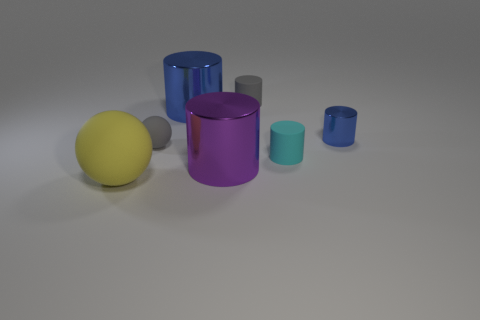Subtract all gray cylinders. How many cylinders are left? 4 Subtract all small blue cylinders. How many cylinders are left? 4 Subtract all yellow cylinders. Subtract all purple blocks. How many cylinders are left? 5 Add 1 blue metal things. How many objects exist? 8 Subtract all cylinders. How many objects are left? 2 Subtract 1 cyan cylinders. How many objects are left? 6 Subtract all big matte blocks. Subtract all big purple cylinders. How many objects are left? 6 Add 6 big cylinders. How many big cylinders are left? 8 Add 3 large yellow spheres. How many large yellow spheres exist? 4 